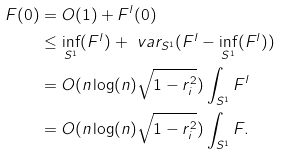<formula> <loc_0><loc_0><loc_500><loc_500>F ( 0 ) & = O ( 1 ) + F ^ { l } ( 0 ) \\ & \leq \inf _ { S ^ { 1 } } ( F ^ { l } ) + \ v a r _ { S ^ { 1 } } ( F ^ { l } - \inf _ { S ^ { 1 } } ( F ^ { l } ) ) \\ & = O ( n \log ( n ) \sqrt { 1 - r _ { i } ^ { 2 } } ) \int _ { S ^ { 1 } } F ^ { l } \\ & = O ( n \log ( n ) \sqrt { 1 - r _ { i } ^ { 2 } } ) \int _ { S ^ { 1 } } F .</formula> 